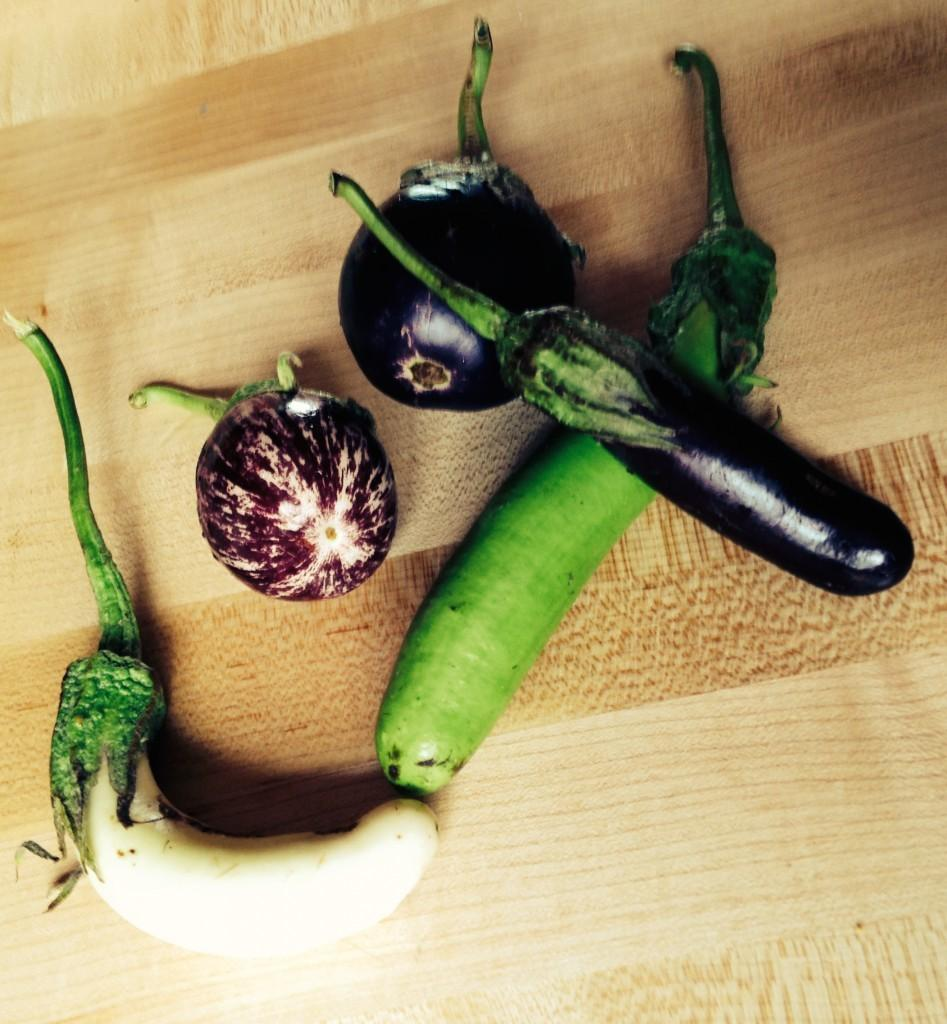What type of table is in the image? There is a wooden table in the image. What is on the table in the image? There are brinjals on the table. What type of sheet is draped over the brinjals in the image? There is no sheet present in the image; it only features a wooden table with brinjals on it. 